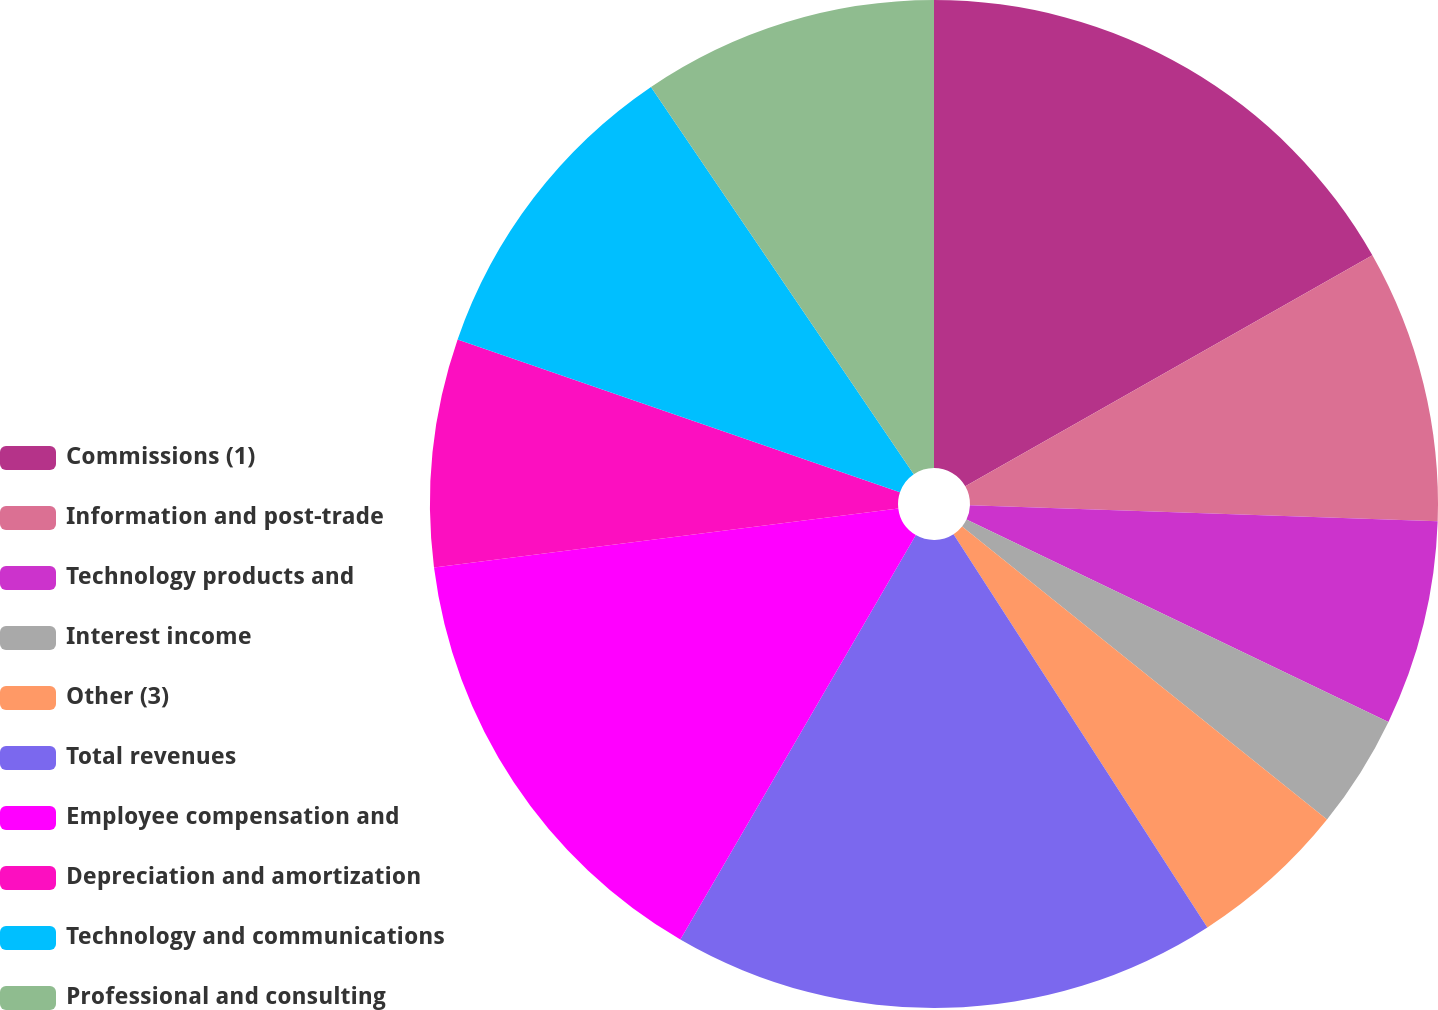Convert chart. <chart><loc_0><loc_0><loc_500><loc_500><pie_chart><fcel>Commissions (1)<fcel>Information and post-trade<fcel>Technology products and<fcel>Interest income<fcel>Other (3)<fcel>Total revenues<fcel>Employee compensation and<fcel>Depreciation and amortization<fcel>Technology and communications<fcel>Professional and consulting<nl><fcel>16.79%<fcel>8.76%<fcel>6.57%<fcel>3.65%<fcel>5.11%<fcel>17.52%<fcel>14.6%<fcel>7.3%<fcel>10.22%<fcel>9.49%<nl></chart> 